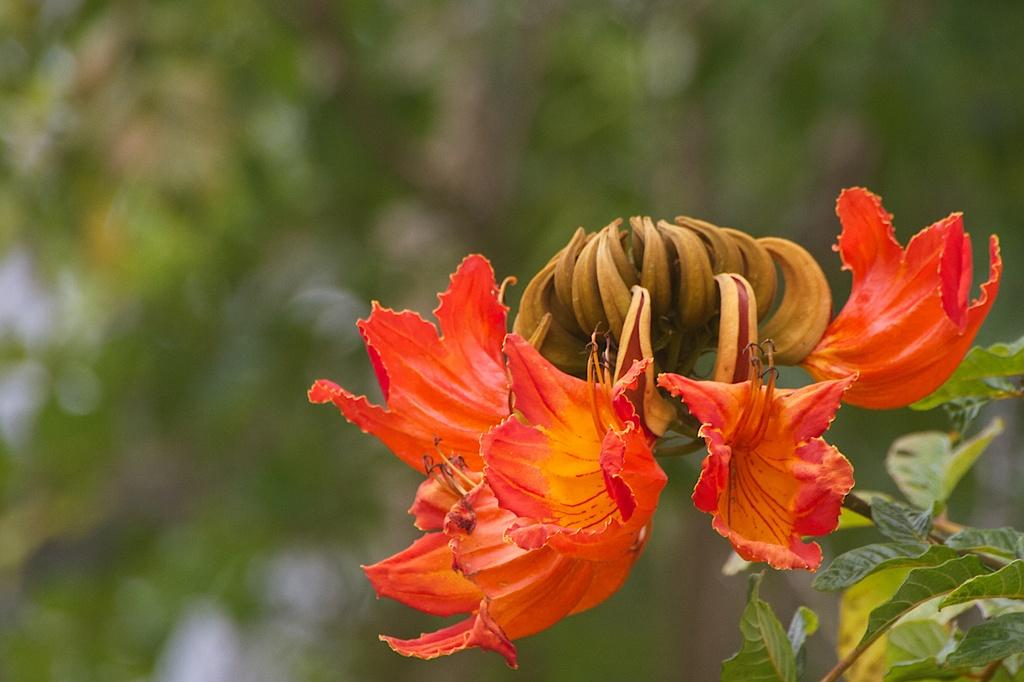What is the main subject of the image? There is a flower in the image. What can be seen in the background of the image? There are leaves visible in the background of the image. What is the rate of the plane flying in the image? There is no plane present in the image, so it is not possible to determine the rate at which it might be flying. 